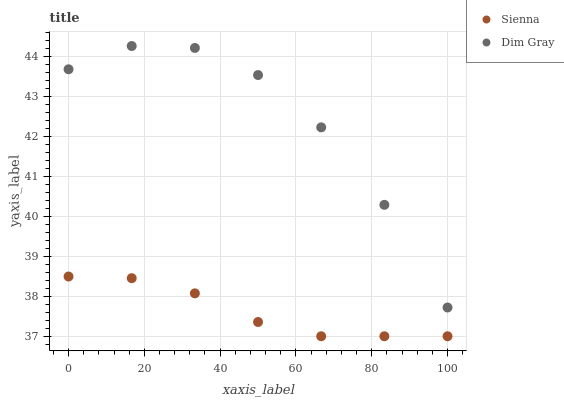Does Sienna have the minimum area under the curve?
Answer yes or no. Yes. Does Dim Gray have the maximum area under the curve?
Answer yes or no. Yes. Does Dim Gray have the minimum area under the curve?
Answer yes or no. No. Is Sienna the smoothest?
Answer yes or no. Yes. Is Dim Gray the roughest?
Answer yes or no. Yes. Is Dim Gray the smoothest?
Answer yes or no. No. Does Sienna have the lowest value?
Answer yes or no. Yes. Does Dim Gray have the lowest value?
Answer yes or no. No. Does Dim Gray have the highest value?
Answer yes or no. Yes. Is Sienna less than Dim Gray?
Answer yes or no. Yes. Is Dim Gray greater than Sienna?
Answer yes or no. Yes. Does Sienna intersect Dim Gray?
Answer yes or no. No. 